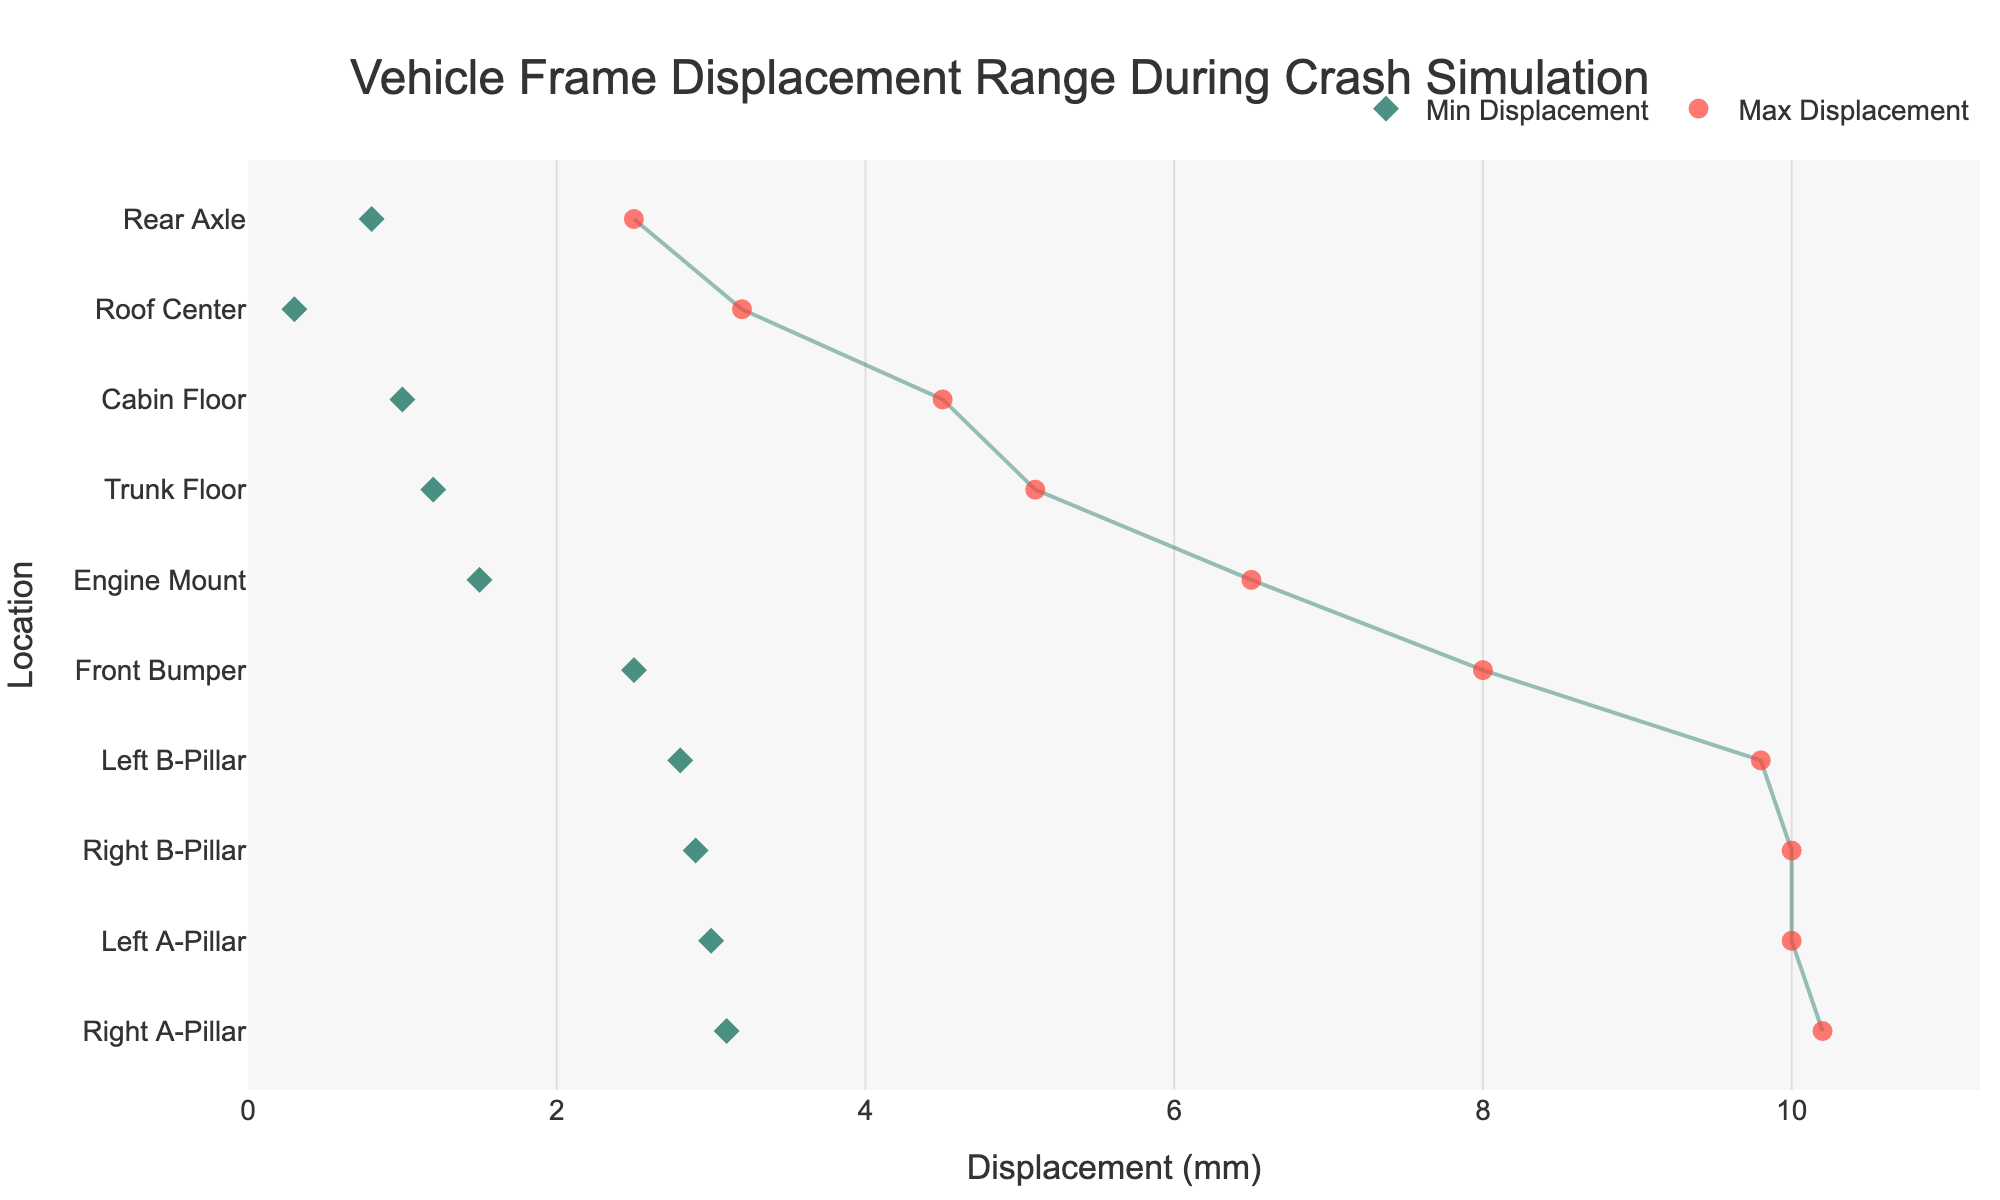Which location has the highest maximum displacement? To find the location with the highest maximum displacement, look for the point with the highest value on the x-axis among the Max Displacement points. The Right A-Pillar shows the highest maximum displacement at 10.2 mm.
Answer: Right A-Pillar Which position shows the smallest minimum displacement? To identify the smallest minimum displacement, look for the point with the lowest value on the x-axis among the Min Displacement points. The Roof Center exhibits the smallest minimum displacement at 0.3 mm.
Answer: Roof Center What is the average displacement for the Left A-Pillar? To calculate the average displacement for the Left A-Pillar, add its minimum and maximum displacement values and divide by 2: (3.0 + 10.0) / 2 = 6.5 mm.
Answer: 6.5 mm Which locations have a wider displacement range, the Left A-Pillar or the Engine Mount? The range for each can be found by subtracting the minimum displacement from the maximum displacement. For the Left A-Pillar: 10.0 - 3.0 = 7.0 mm. For the Engine Mount: 6.5 - 1.5 = 5.0 mm. The Left A-Pillar has a wider range.
Answer: Left A-Pillar How many locations have a maximum displacement of over 5.0 mm? Count the number of data points (Max Displacement values) that are greater than 5.0 mm. These points are: Front Bumper, Engine Mount, Left A-Pillar, Right A-Pillar, Cabin Floor, Left B-Pillar, Right B-Pillar, Trunk Floor—totaling 8 locations.
Answer: 8 What is the total displacement range for the Rear Axle? Calculate the displacement range for the Rear Axle using the difference between its maximum and minimum displacement values: 2.5 - 0.8 = 1.7 mm.
Answer: 1.7 mm Which location has the closest minimum and maximum displacements? Identify which location has the smallest difference between its minimum and maximum displacement values. For each location, calculate the difference: the Rear Axle has a difference of 1.7 mm, which is the smallest among them.
Answer: Rear Axle What is the median maximum displacement value? To find the median, list the maximum displacement values in ascending order and find the middle value(s): 2.5, 3.2, 4.5, 5.1, 6.5, 8.0, 9.8, 10.0, 10.0, 10.2. Since there is an even number of points, the median is the average of the 5th and 6th values: (6.5 + 8.0) / 2 = 7.25 mm.
Answer: 7.25 mm Is the displacement at the Trunk Floor generally higher or lower than that of the Left B-Pillar? Compare the minimum and maximum displacement values of both locations. The Trunk Floor: 1.2 mm to 5.1 mm. The Left B-Pillar: 2.8 mm to 9.8 mm. In both minimum and maximum values, the Left B-Pillar exhibits higher displacements.
Answer: Lower 